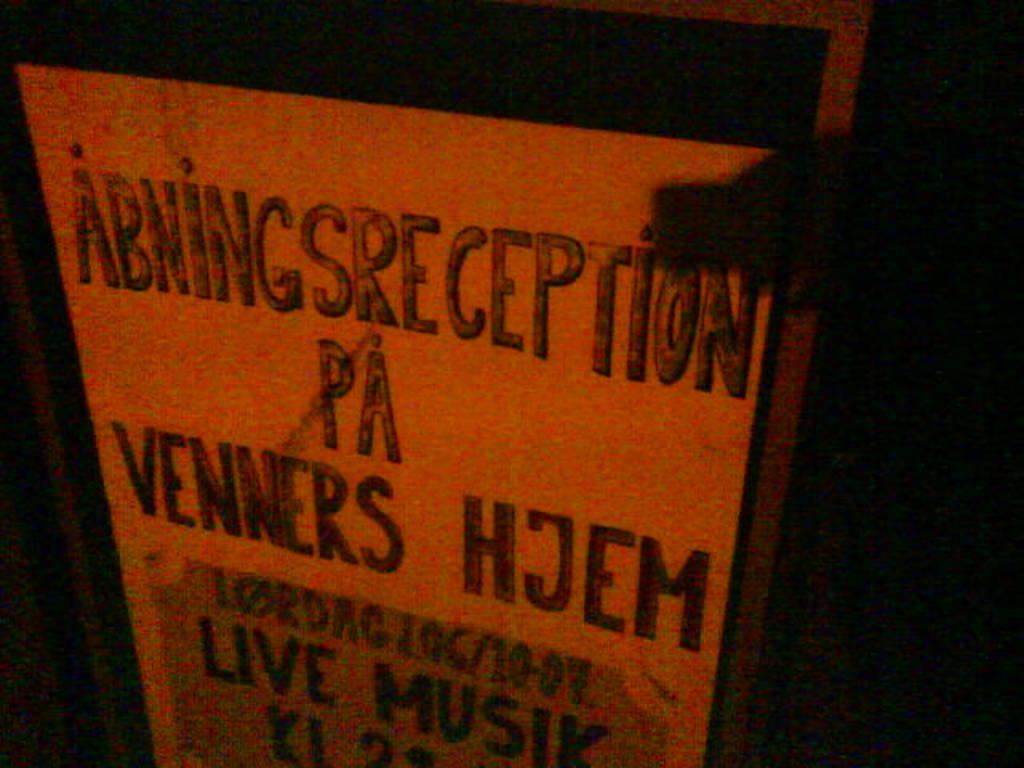Provide a one-sentence caption for the provided image. White sign with black wording that say "Abningsreception pa venners hjem". 